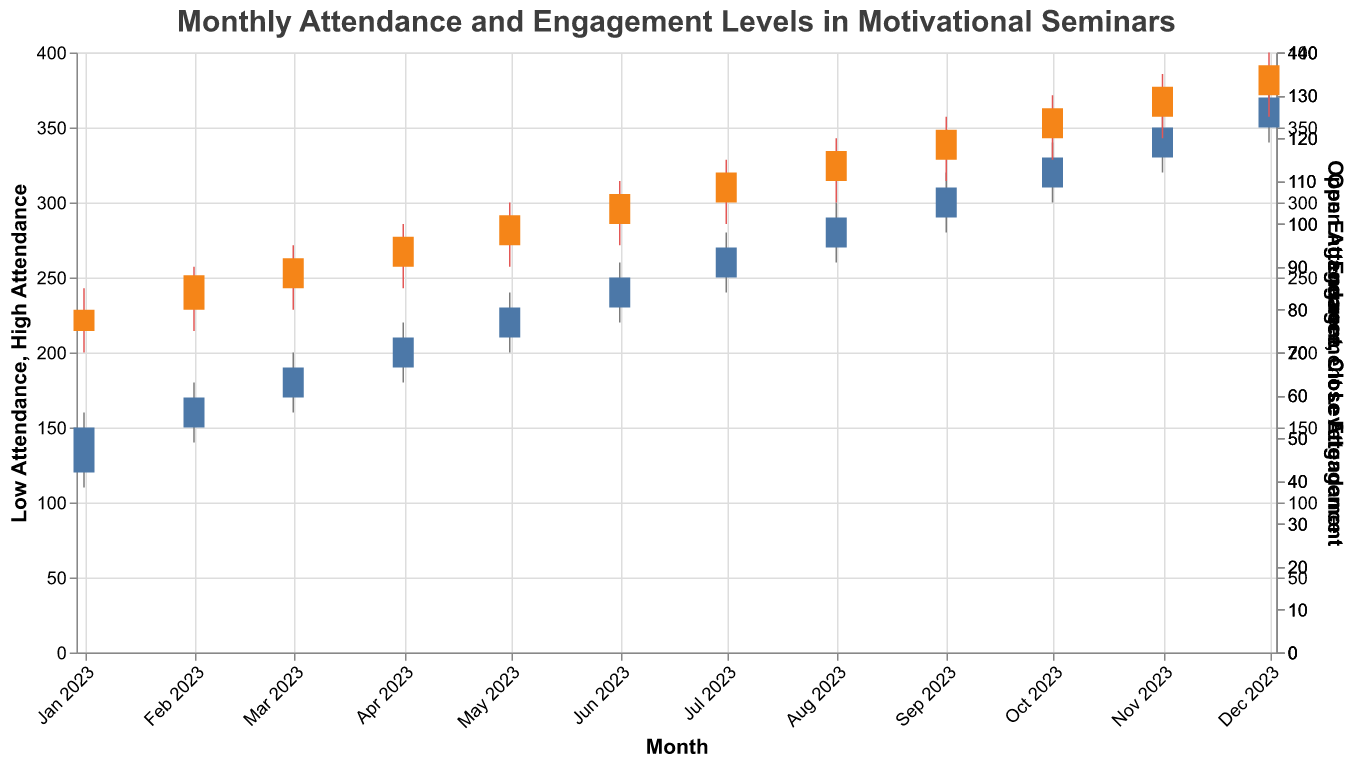What is the title of the candlestick plot? The plot's title is prominently displayed at the top and reads "Monthly Attendance and Engagement Levels in Motivational Seminars", which helps the viewer understand what data is being visualized.
Answer: Monthly Attendance and Engagement Levels in Motivational Seminars What are the maximum and minimum attendance levels recorded in January 2023? The maximum attendance level is represented by the highest point on the candlestick for January and the minimum by the lowest. From the data, the high is 160 and the low is 110.
Answer: Maximum: 160, Minimum: 110 How does the engagement level in February 2023 compare to January 2023? To compare, we look at the "Close Engagement" values for January and February, which are 80 and 88 respectively. This indicates an increase.
Answer: February is higher What is the overall trend in attendance from January to December 2023? By examining the "Close Attendance" values, we notice that the candlesticks generally rise each month, indicating an upward trend in attendance.
Answer: Upward trend What is the range of engagement levels in March 2023? The range is calculated by subtracting the "Low Engagement" value from the "High Engagement" value for March, which is 95 - 80 = 15.
Answer: 15 Which month recorded the highest closing engagement level? To find the highest closing engagement level, we compare the "Close Engagement" values for each month. December records the highest closing engagement level at 137.
Answer: December What is the difference between open and close attendance levels in August 2023? The difference is found by subtracting the "Open Attendance" from the "Close Attendance" for August, which is 290 - 270 = 20.
Answer: 20 Which month showed the greatest increase in attendance from open to close? To find this, we calculate the difference between "Open Attendance" and "Close Attendance" for each month, and find the greatest value. June shows the greatest increase (250 - 230 = 20).
Answer: June How does the engagement level in July 2023 compare to that in December 2023? The "Close Engagement" for July is 112, and for December, it's 137, indicating that December has a higher engagement level.
Answer: December is higher Was there any month where attendance decreased from open to close? We need to check for any month where the "Close Attendance" is less than the "Open Attendance". None of the months show a decrease since all close values are higher than the open views.
Answer: No 